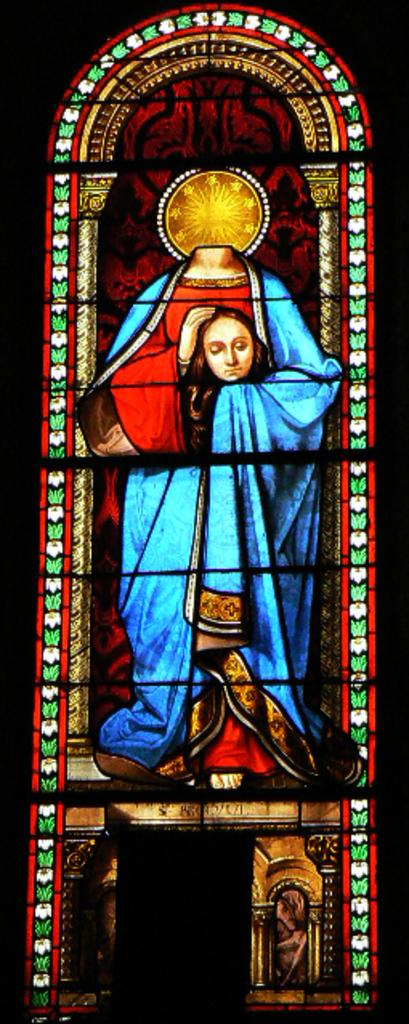What type of glass can be seen in the image? There is stained glass in the image. What is depicted on the stained glass? The stained glass contains a depiction of a person. Are there any other elements on the stained glass besides the person? Yes, the stained glass also contains some designs. What type of whip is being used by the person depicted on the stained glass? There is no whip present in the image; the stained glass contains a depiction of a person and some designs, but no whip. 